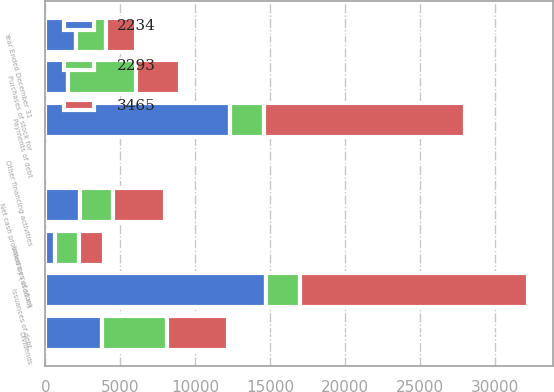Convert chart. <chart><loc_0><loc_0><loc_500><loc_500><stacked_bar_chart><ecel><fcel>Year Ended December 31<fcel>Issuances of debt<fcel>Payments of debt<fcel>Issuances of stock<fcel>Purchases of stock for<fcel>Dividends<fcel>Other financing activities<fcel>Net cash provided by (used in)<nl><fcel>2293<fcel>2011<fcel>2263.5<fcel>2263.5<fcel>1569<fcel>4513<fcel>4300<fcel>45<fcel>2234<nl><fcel>3465<fcel>2010<fcel>15251<fcel>13403<fcel>1666<fcel>2961<fcel>4068<fcel>50<fcel>3465<nl><fcel>2234<fcel>2009<fcel>14689<fcel>12326<fcel>664<fcel>1518<fcel>3800<fcel>2<fcel>2293<nl></chart> 